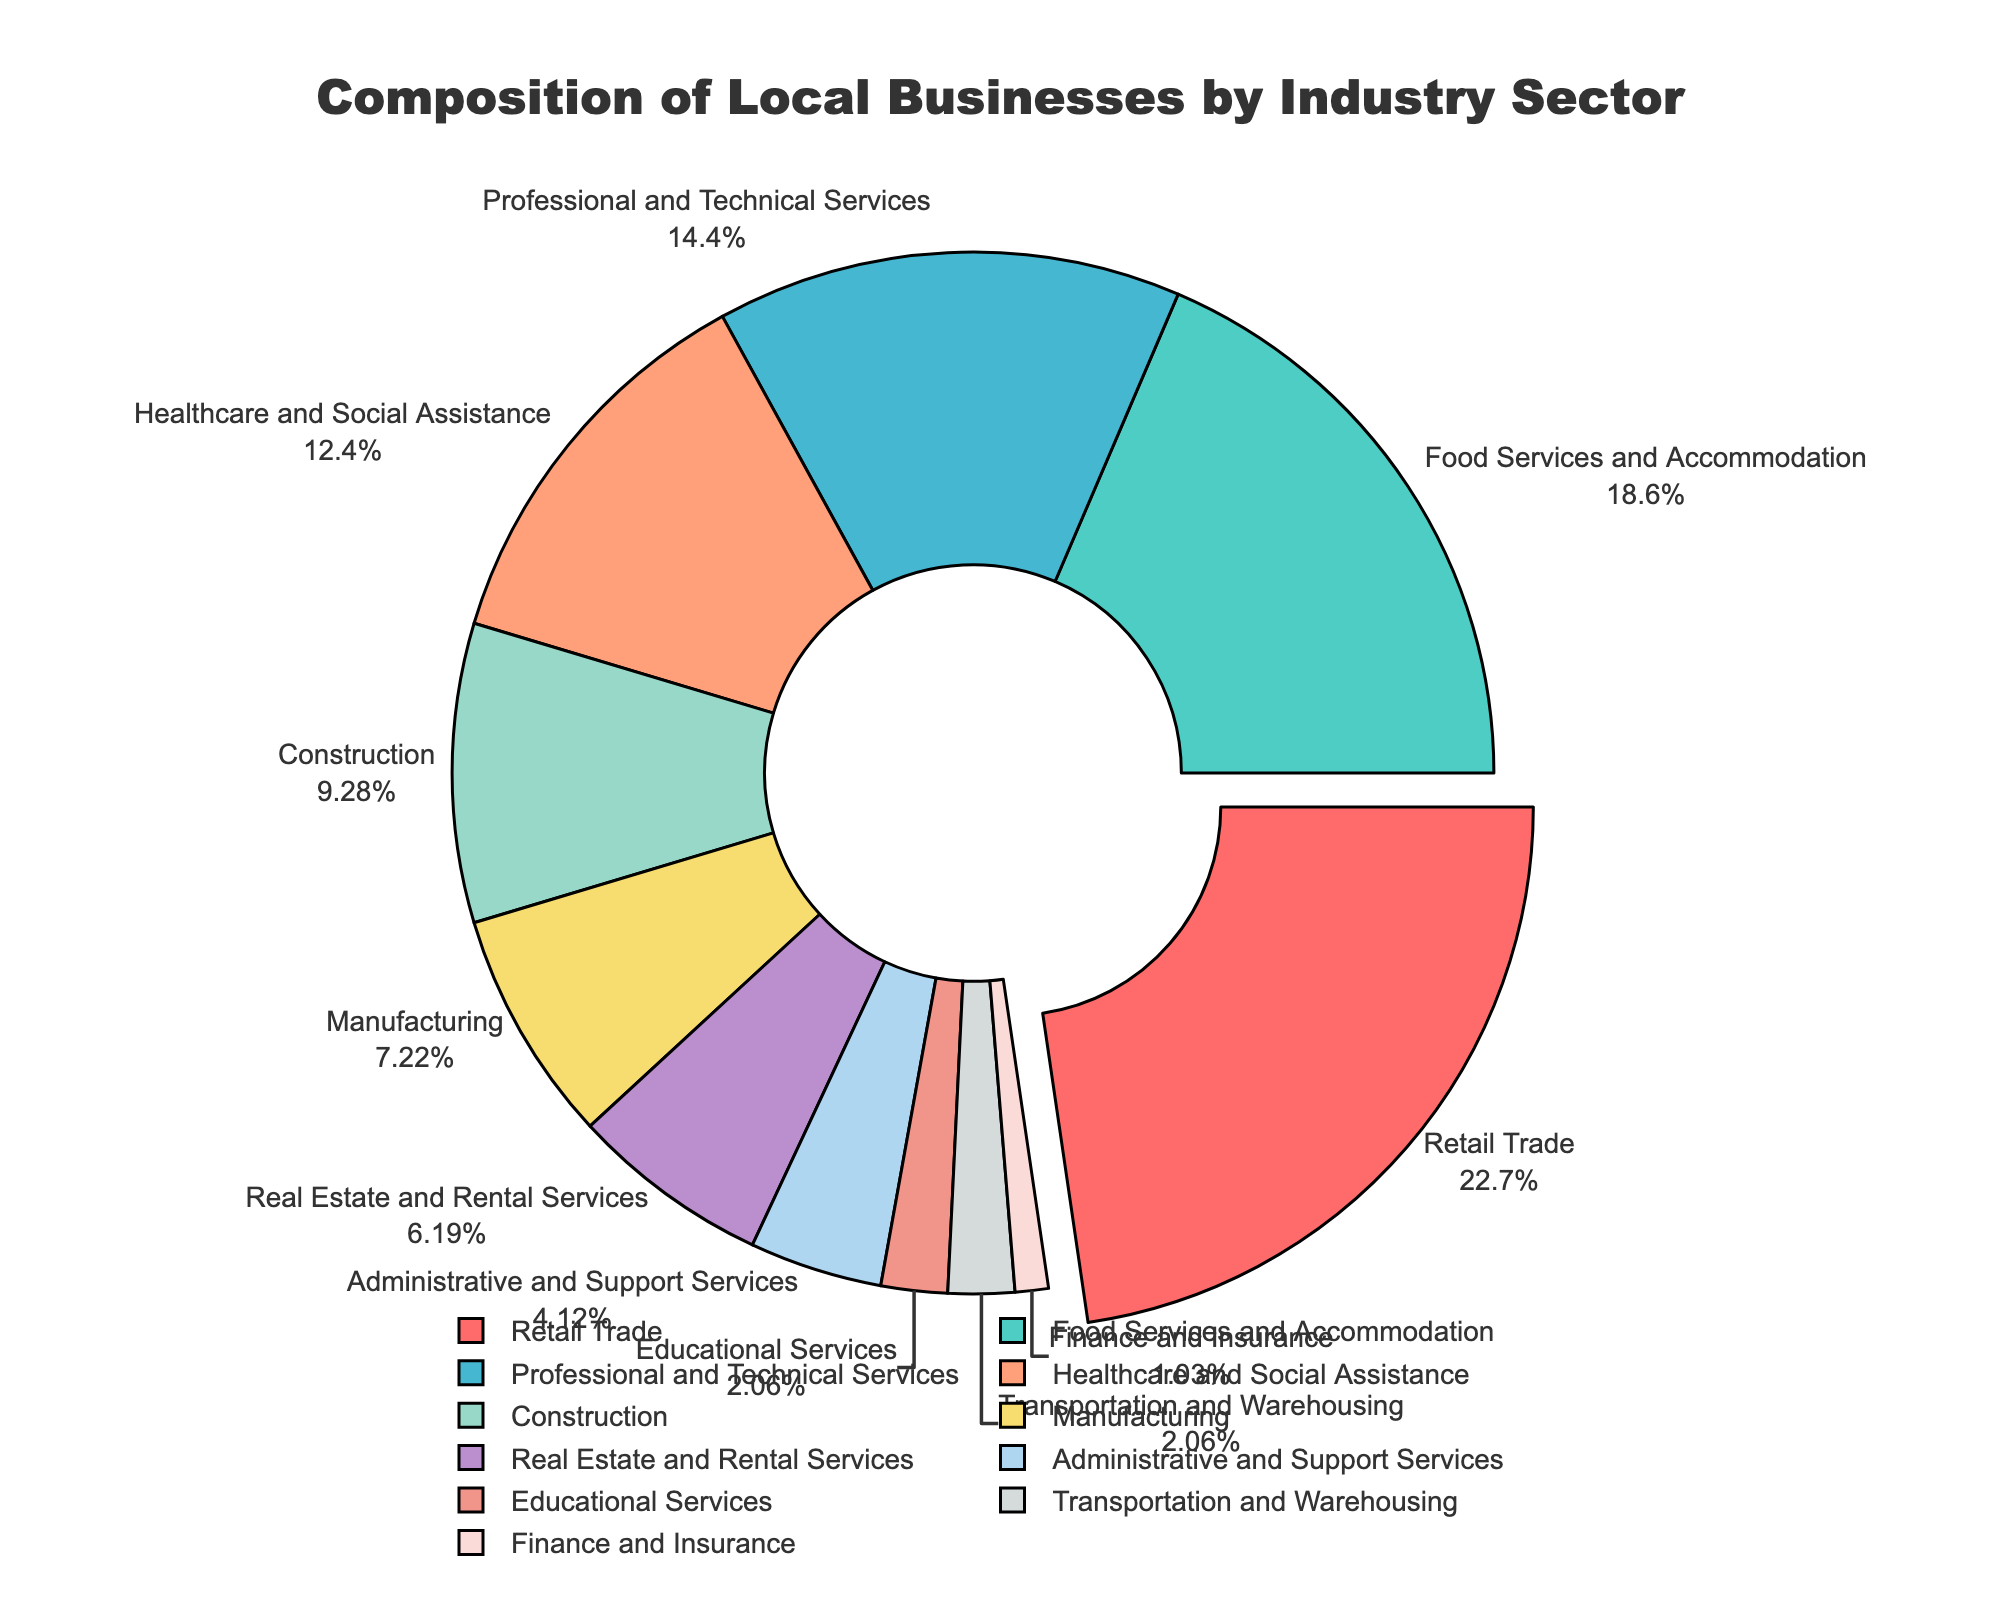What industry sector has the largest share of local businesses? The sector with the largest percentage in the pie chart is the Retail Trade sector, which stands out because it also has a slight pull-out effect from the pie.
Answer: Retail Trade What is the total percentage of local businesses in the Food Services and Accommodation and Professional and Technical Services sectors combined? To find the combined total, add the percentages of the Food Services and Accommodation (18%) and the Professional and Technical Services (14%) sectors. 18% + 14% = 32%
Answer: 32% Which sector has a smaller percentage of local businesses: Healthcare and Social Assistance or Construction? Compare the percentages of the two sectors: Healthcare and Social Assistance has 12%, and Construction has 9%. Since 9% is less than 12%, Construction has a smaller share.
Answer: Construction How much larger in percentage is the Retail Trade sector compared to the Transportation and Warehousing sector? Subtract the percentage of the Transportation and Warehousing sector (2%) from the Retail Trade sector (22%). 22% - 2% = 20%
Answer: 20% What is the average percentage of local businesses in the top three sectors? The top three sectors are Retail Trade (22%), Food Services and Accommodation (18%), and Professional and Technical Services (14%). First, sum the percentages: 22% + 18% + 14% = 54%. Then, divide by 3 to find the average. 54% / 3 = 18%
Answer: 18% Are there more local businesses in the Manufacturing sector or the Real Estate and Rental Services sector? Compare the percentages of the Manufacturing sector (7%) with the Real Estate and Rental Services sector (6%). Since 7% is more than 6%, there are more businesses in the Manufacturing sector.
Answer: Manufacturing What is the combined percentage of local businesses in the sectors that each have 2% or less? The sectors with 2% each are Educational Services (2%) and Transportation and Warehousing (2%), and Finance and Insurance (1%). Add these percentages: 2% + 2% + 1% = 5%
Answer: 5% Which color represents the Healthcare and Social Assistance sector in the pie chart? By looking at the colors assigned and the labels outside the pie, the Healthcare and Social Assistance sector is represented by a color (light yellow) near the center-left side of the chart.
Answer: Light Yellow How many sectors have a percentage of local businesses greater than or equal to 10%? Compare each sector's percentage to 10%. Retail Trade, Food Services and Accommodation, Professional and Technical Services, and Healthcare and Social Assistance, totaling 4 sectors, each have percentages greater than or equal to 10%.
Answer: 4 